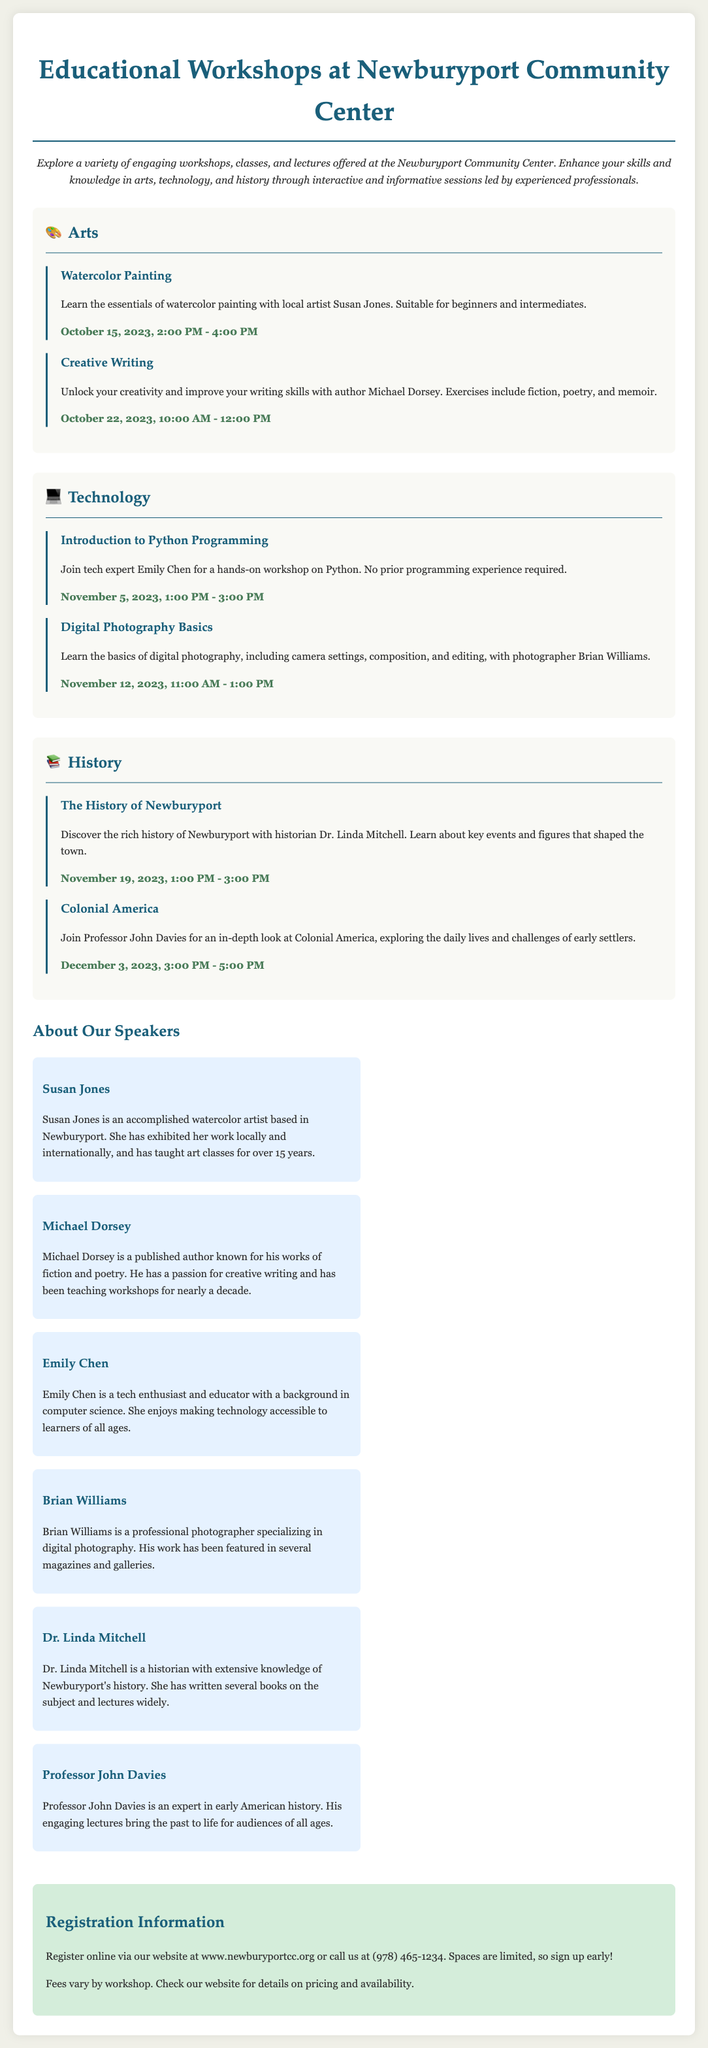What is the title of the flyer? The title of the flyer is prominently displayed at the top of the document.
Answer: Educational Workshops at Newburyport Community Center What is the date and time of the Watercolor Painting workshop? The date and time for this workshop is mentioned in the arts section.
Answer: October 15, 2023, 2:00 PM - 4:00 PM Who is the speaker for the Digital Photography Basics workshop? The speaker's name is included with the workshop details in the technology section.
Answer: Brian Williams What is the focus of the History of Newburyport workshop? The focus of the workshop is described in the historical context section.
Answer: Rich history of Newburyport How many workshops are listed under the arts section? The number of workshops can be counted in the arts section of the flyer.
Answer: 2 What type of icon is used to represent the Technology section? The icon associated with the technology section is specified at the start of that section.
Answer: 💻 When does registration begin for these workshops? This information is typically provided in the registration section.
Answer: Not specified Who is teaching the Introduction to Python Programming workshop? The teacher’s name is included with the workshop details in the technology section.
Answer: Emily Chen What should participants do to register for workshops? This action is outlined in the registration information segment of the flyer.
Answer: Register online or call What is the background of Dr. Linda Mitchell? Her background is summarized in her speaker bio section in the document.
Answer: Historian with extensive knowledge of Newburyport's history 